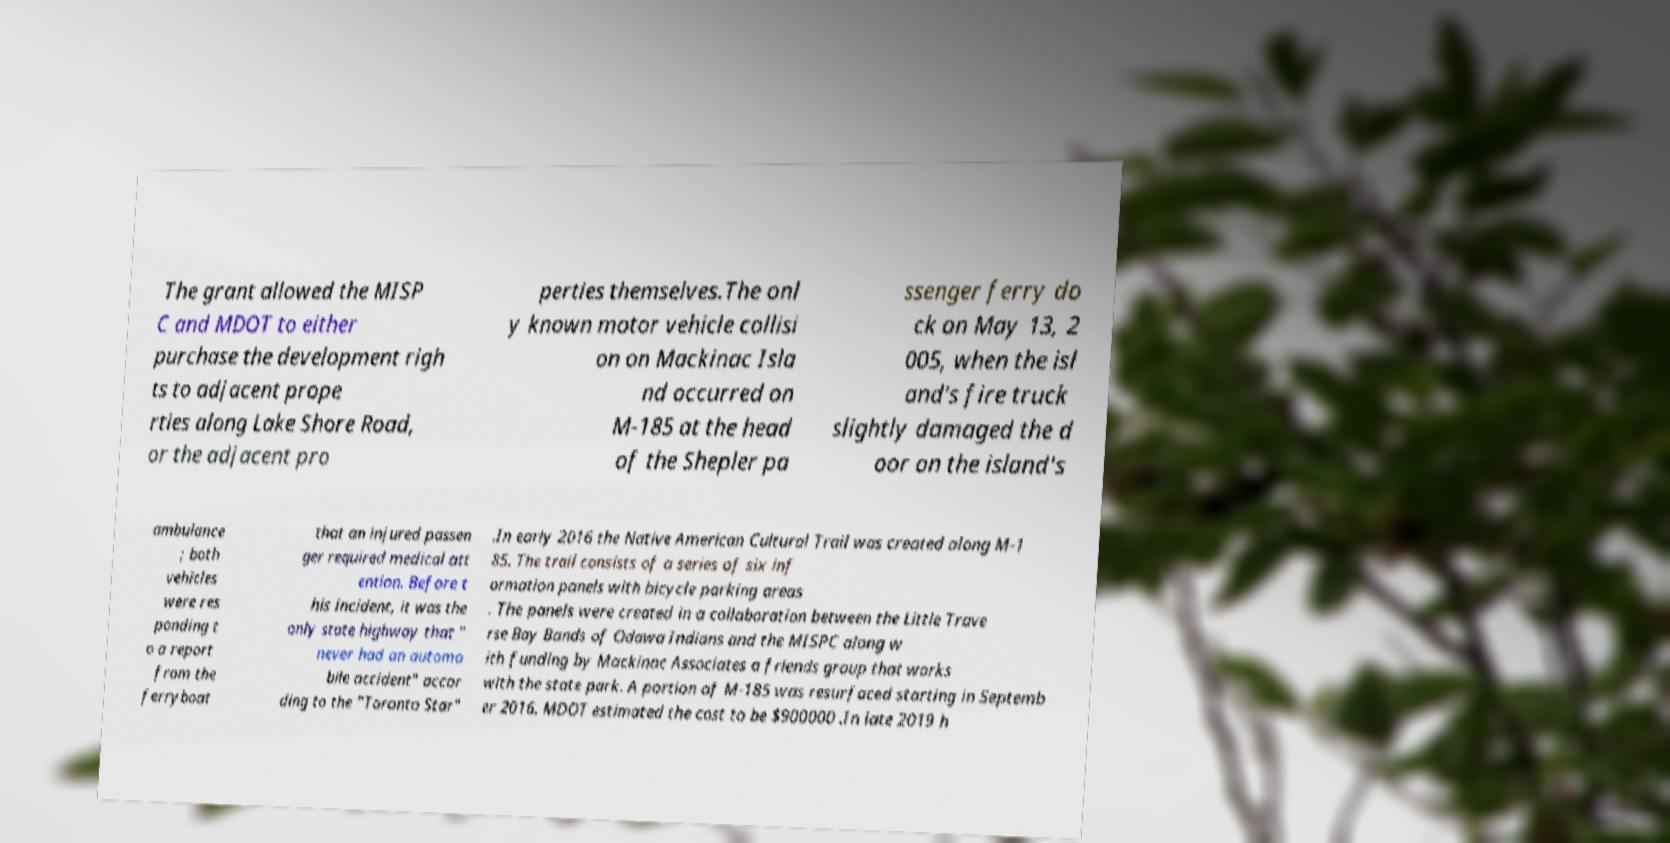Could you extract and type out the text from this image? The grant allowed the MISP C and MDOT to either purchase the development righ ts to adjacent prope rties along Lake Shore Road, or the adjacent pro perties themselves.The onl y known motor vehicle collisi on on Mackinac Isla nd occurred on M-185 at the head of the Shepler pa ssenger ferry do ck on May 13, 2 005, when the isl and's fire truck slightly damaged the d oor on the island's ambulance ; both vehicles were res ponding t o a report from the ferryboat that an injured passen ger required medical att ention. Before t his incident, it was the only state highway that " never had an automo bile accident" accor ding to the "Toronto Star" .In early 2016 the Native American Cultural Trail was created along M-1 85. The trail consists of a series of six inf ormation panels with bicycle parking areas . The panels were created in a collaboration between the Little Trave rse Bay Bands of Odawa Indians and the MISPC along w ith funding by Mackinac Associates a friends group that works with the state park. A portion of M-185 was resurfaced starting in Septemb er 2016. MDOT estimated the cost to be $900000 .In late 2019 h 